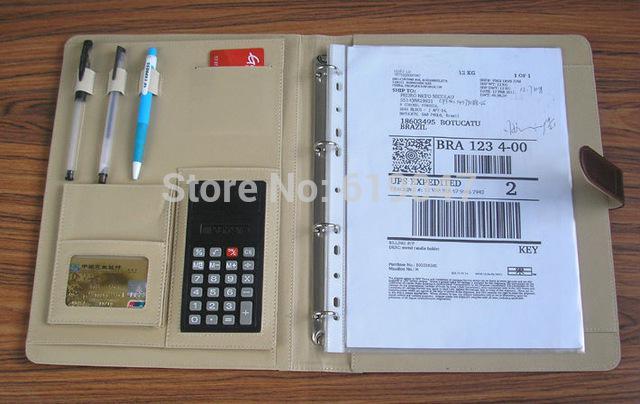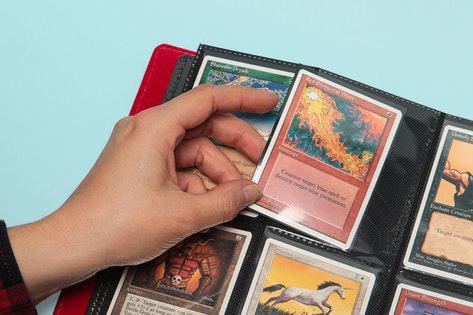The first image is the image on the left, the second image is the image on the right. Analyze the images presented: Is the assertion "One binder is bright blue." valid? Answer yes or no. No. 